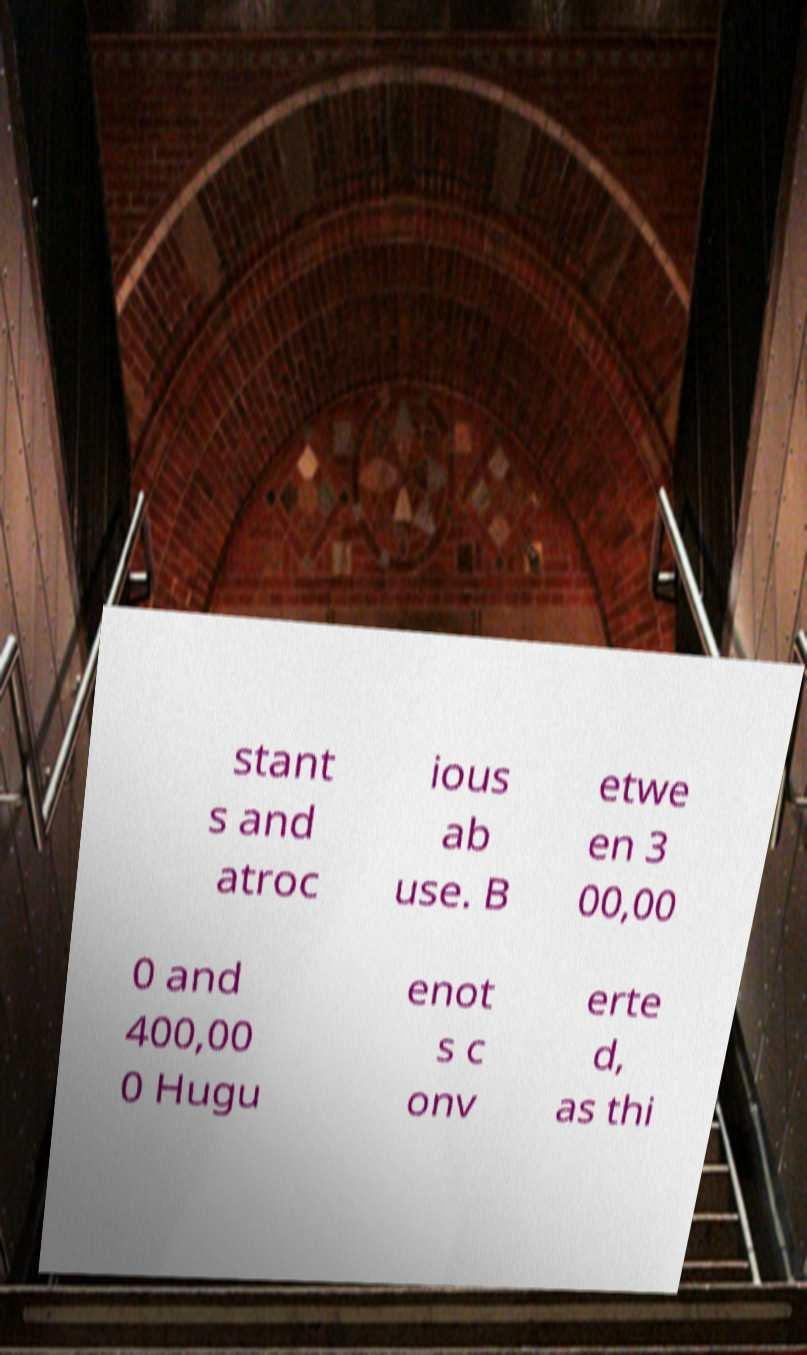Can you accurately transcribe the text from the provided image for me? stant s and atroc ious ab use. B etwe en 3 00,00 0 and 400,00 0 Hugu enot s c onv erte d, as thi 